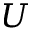Convert formula to latex. <formula><loc_0><loc_0><loc_500><loc_500>U</formula> 